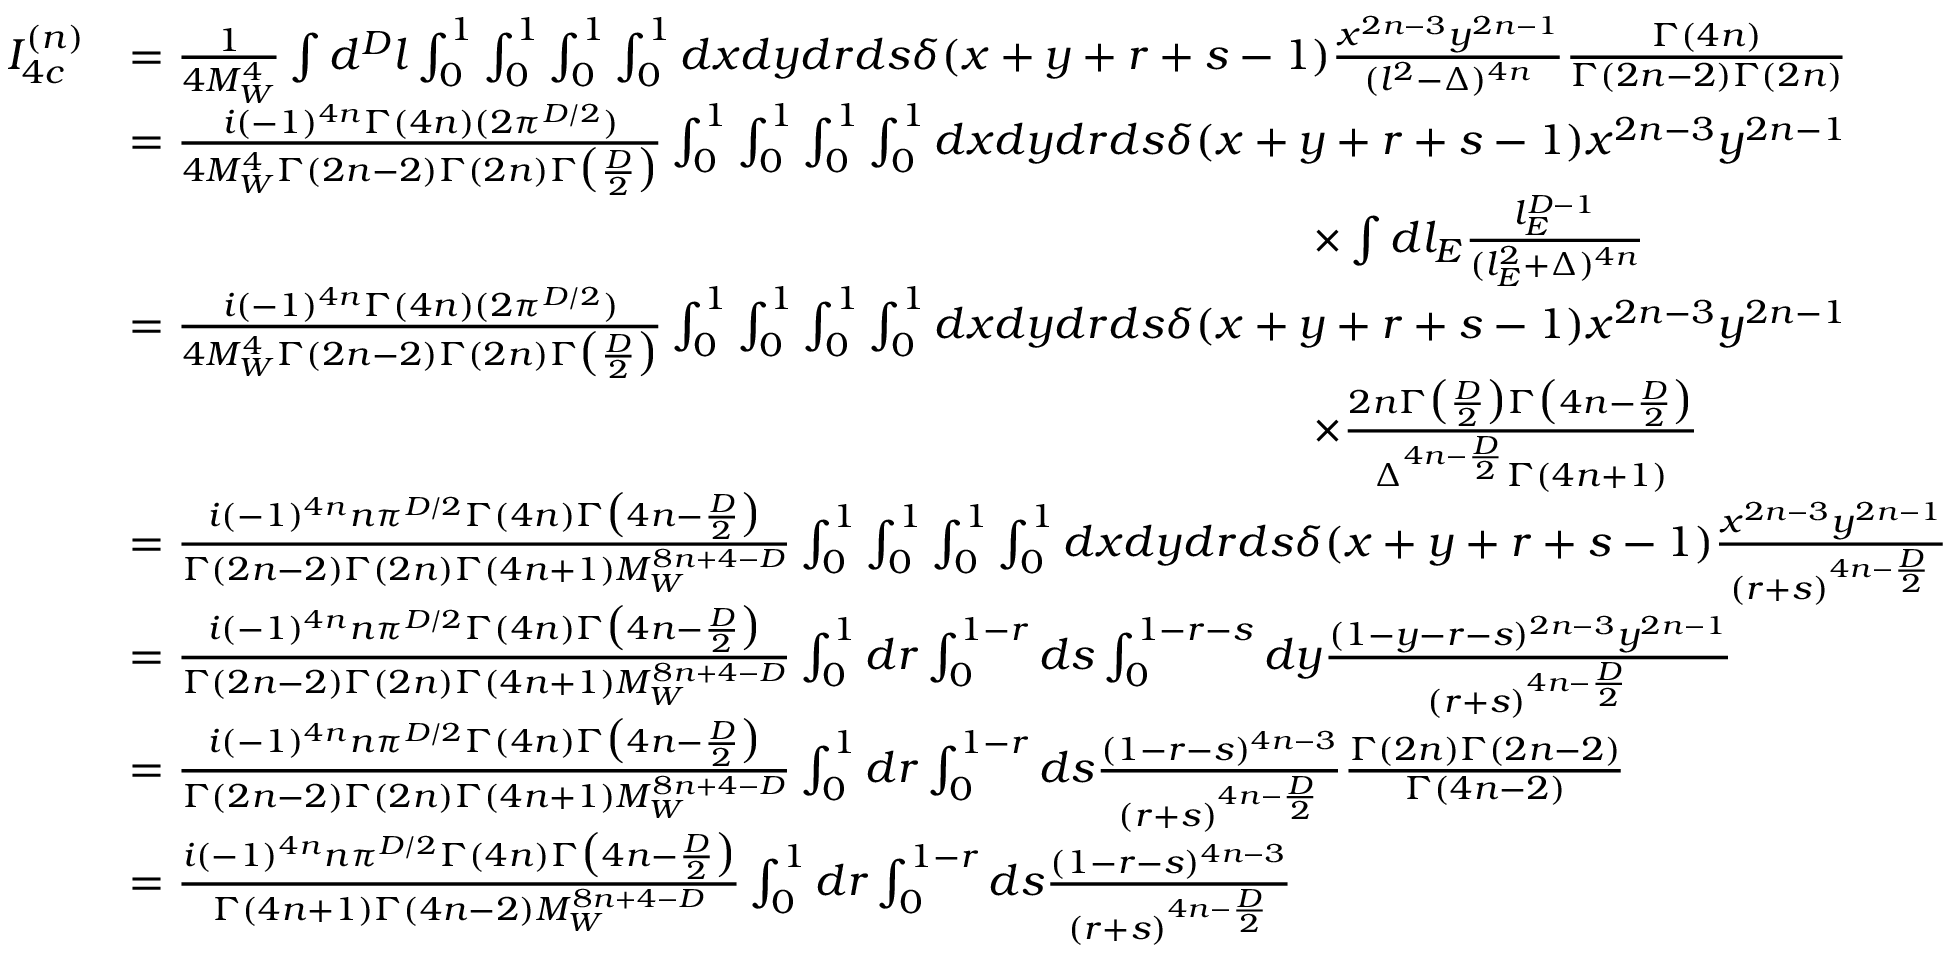Convert formula to latex. <formula><loc_0><loc_0><loc_500><loc_500>\begin{array} { r l } { I _ { 4 c } ^ { ( n ) } } & { = \frac { 1 } { 4 M _ { W } ^ { 4 } } \int d ^ { D } l \int _ { 0 } ^ { 1 } \int _ { 0 } ^ { 1 } \int _ { 0 } ^ { 1 } \int _ { 0 } ^ { 1 } d x d y d r d s \delta ( x + y + r + s - 1 ) \frac { x ^ { 2 n - 3 } y ^ { 2 n - 1 } } { ( l ^ { 2 } - \Delta ) ^ { 4 n } } \frac { \Gamma ( 4 n ) } { \Gamma ( 2 n - 2 ) \Gamma ( 2 n ) } } \\ & { = \frac { i ( - 1 ) ^ { 4 n } \Gamma ( 4 n ) ( 2 \pi ^ { D / 2 } ) } { 4 M _ { W } ^ { 4 } \Gamma ( 2 n - 2 ) \Gamma ( 2 n ) \Gamma \left ( \frac { D } { 2 } \right ) } \int _ { 0 } ^ { 1 } \int _ { 0 } ^ { 1 } \int _ { 0 } ^ { 1 } \int _ { 0 } ^ { 1 } d x d y d r d s \delta ( x + y + r + s - 1 ) x ^ { 2 n - 3 } y ^ { 2 n - 1 } } \\ & { \quad \times \int d l _ { E } \frac { l _ { E } ^ { D - 1 } } { ( l _ { E } ^ { 2 } + \Delta ) ^ { 4 n } } } \\ & { = \frac { i ( - 1 ) ^ { 4 n } \Gamma ( 4 n ) ( 2 \pi ^ { D / 2 } ) } { 4 M _ { W } ^ { 4 } \Gamma ( 2 n - 2 ) \Gamma ( 2 n ) \Gamma \left ( \frac { D } { 2 } \right ) } \int _ { 0 } ^ { 1 } \int _ { 0 } ^ { 1 } \int _ { 0 } ^ { 1 } \int _ { 0 } ^ { 1 } d x d y d r d s \delta ( x + y + r + s - 1 ) x ^ { 2 n - 3 } y ^ { 2 n - 1 } } \\ & { \quad \times \frac { 2 n \Gamma \left ( \frac { D } { 2 } \right ) \Gamma \left ( 4 n - \frac { D } { 2 } \right ) } { \Delta ^ { 4 n - \frac { D } { 2 } } \Gamma ( 4 n + 1 ) } } \\ & { = \frac { i ( - 1 ) ^ { 4 n } n \pi ^ { D / 2 } \Gamma ( 4 n ) \Gamma \left ( 4 n - \frac { D } { 2 } \right ) } { \Gamma ( 2 n - 2 ) \Gamma ( 2 n ) \Gamma ( 4 n + 1 ) M _ { W } ^ { 8 n + 4 - D } } \int _ { 0 } ^ { 1 } \int _ { 0 } ^ { 1 } \int _ { 0 } ^ { 1 } \int _ { 0 } ^ { 1 } d x d y d r d s \delta ( x + y + r + s - 1 ) \frac { x ^ { 2 n - 3 } y ^ { 2 n - 1 } } { ( r + s ) ^ { 4 n - \frac { D } { 2 } } } } \\ & { = \frac { i ( - 1 ) ^ { 4 n } n \pi ^ { D / 2 } \Gamma ( 4 n ) \Gamma \left ( 4 n - \frac { D } { 2 } \right ) } { \Gamma ( 2 n - 2 ) \Gamma ( 2 n ) \Gamma ( 4 n + 1 ) M _ { W } ^ { 8 n + 4 - D } } \int _ { 0 } ^ { 1 } d r \int _ { 0 } ^ { 1 - r } d s \int _ { 0 } ^ { 1 - r - s } d y \frac { ( 1 - y - r - s ) ^ { 2 n - 3 } y ^ { 2 n - 1 } } { ( r + s ) ^ { 4 n - \frac { D } { 2 } } } } \\ & { = \frac { i ( - 1 ) ^ { 4 n } n \pi ^ { D / 2 } \Gamma ( 4 n ) \Gamma \left ( 4 n - \frac { D } { 2 } \right ) } { \Gamma ( 2 n - 2 ) \Gamma ( 2 n ) \Gamma ( 4 n + 1 ) M _ { W } ^ { 8 n + 4 - D } } \int _ { 0 } ^ { 1 } d r \int _ { 0 } ^ { 1 - r } d s \frac { ( 1 - r - s ) ^ { 4 n - 3 } } { ( r + s ) ^ { 4 n - \frac { D } { 2 } } } \frac { \Gamma ( 2 n ) \Gamma ( 2 n - 2 ) } { \Gamma ( 4 n - 2 ) } } \\ & { = \frac { i ( - 1 ) ^ { 4 n } n \pi ^ { D / 2 } \Gamma ( 4 n ) \Gamma \left ( 4 n - \frac { D } { 2 } \right ) } { \Gamma ( 4 n + 1 ) \Gamma ( 4 n - 2 ) M _ { W } ^ { 8 n + 4 - D } } \int _ { 0 } ^ { 1 } d r \int _ { 0 } ^ { 1 - r } d s \frac { ( 1 - r - s ) ^ { 4 n - 3 } } { ( r + s ) ^ { 4 n - \frac { D } { 2 } } } } \end{array}</formula> 